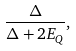<formula> <loc_0><loc_0><loc_500><loc_500>\frac { \Delta } { \Delta + 2 E _ { Q } } ,</formula> 